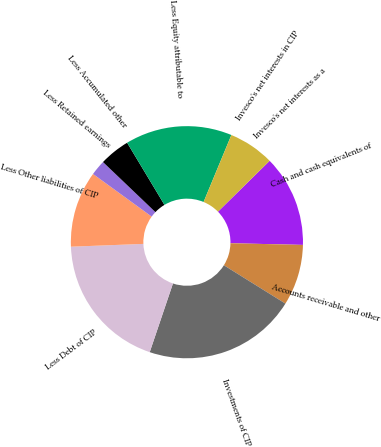Convert chart to OTSL. <chart><loc_0><loc_0><loc_500><loc_500><pie_chart><fcel>Cash and cash equivalents of<fcel>Accounts receivable and other<fcel>Investments of CIP<fcel>Less Debt of CIP<fcel>Less Other liabilities of CIP<fcel>Less Retained earnings<fcel>Less Accumulated other<fcel>Less Equity attributable to<fcel>Invesco's net interests in CIP<fcel>Invesco's net interests as a<nl><fcel>12.74%<fcel>8.5%<fcel>21.32%<fcel>19.19%<fcel>10.62%<fcel>2.13%<fcel>4.25%<fcel>14.87%<fcel>6.37%<fcel>0.0%<nl></chart> 